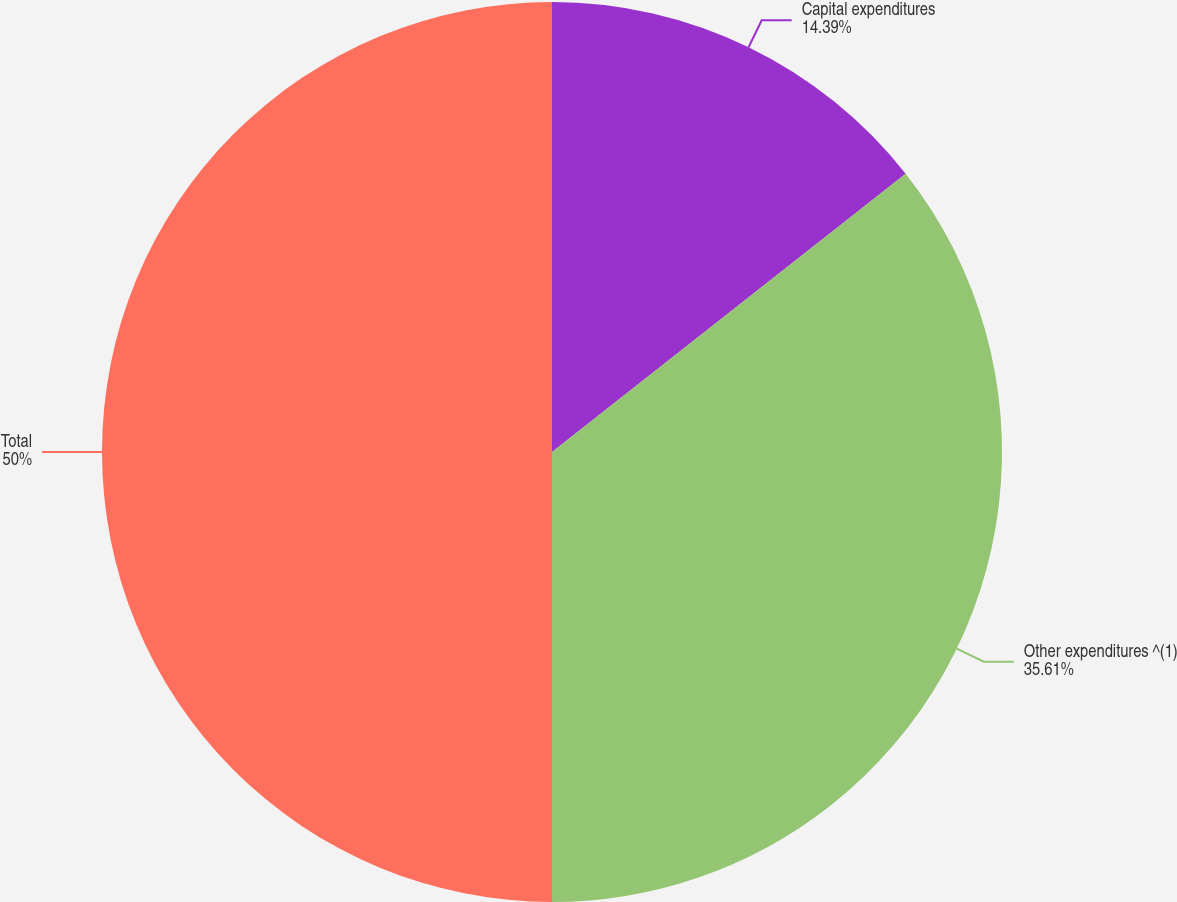Convert chart to OTSL. <chart><loc_0><loc_0><loc_500><loc_500><pie_chart><fcel>Capital expenditures<fcel>Other expenditures ^(1)<fcel>Total<nl><fcel>14.39%<fcel>35.61%<fcel>50.0%<nl></chart> 